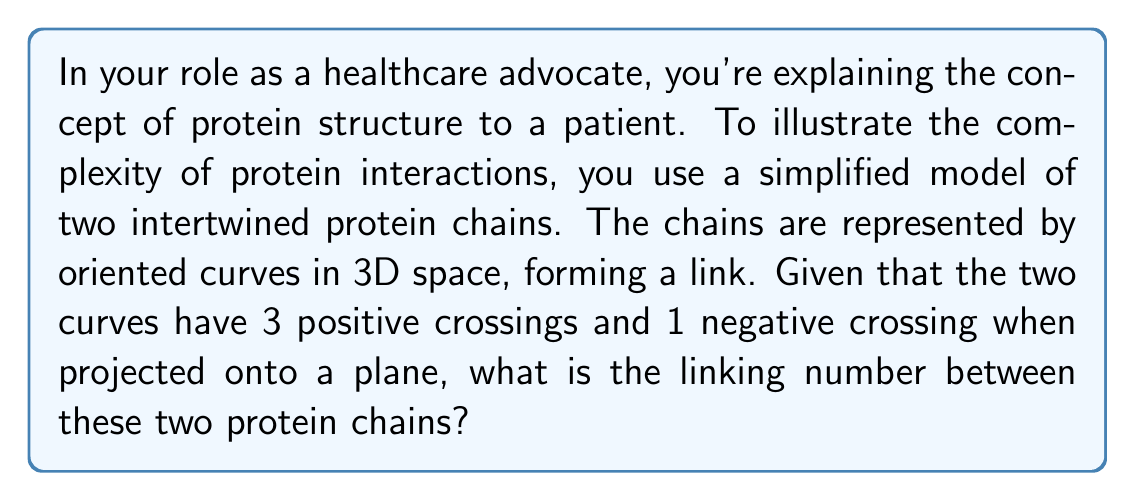Can you solve this math problem? Let's approach this step-by-step:

1) The linking number is a topological invariant that describes how two closed curves are linked in three-dimensional space. It's calculated as half the sum of the signed crossings in a regular projection of the link.

2) The formula for the linking number is:

   $$Lk = \frac{1}{2}\sum_{i} \epsilon_i$$

   where $\epsilon_i$ is the sign of each crossing (+1 for positive, -1 for negative).

3) In this case, we have:
   - 3 positive crossings: $\epsilon_1 = \epsilon_2 = \epsilon_3 = +1$
   - 1 negative crossing: $\epsilon_4 = -1$

4) Let's sum these up:

   $$\sum_{i} \epsilon_i = (+1) + (+1) + (+1) + (-1) = +2$$

5) Now, we apply the formula:

   $$Lk = \frac{1}{2} \cdot (+2) = +1$$

Therefore, the linking number between the two protein chains is +1.

This means that the two chains are indeed linked and cannot be separated without breaking one of them, which is a simplified representation of how protein interactions can be stable and significant in biological processes.
Answer: $+1$ 